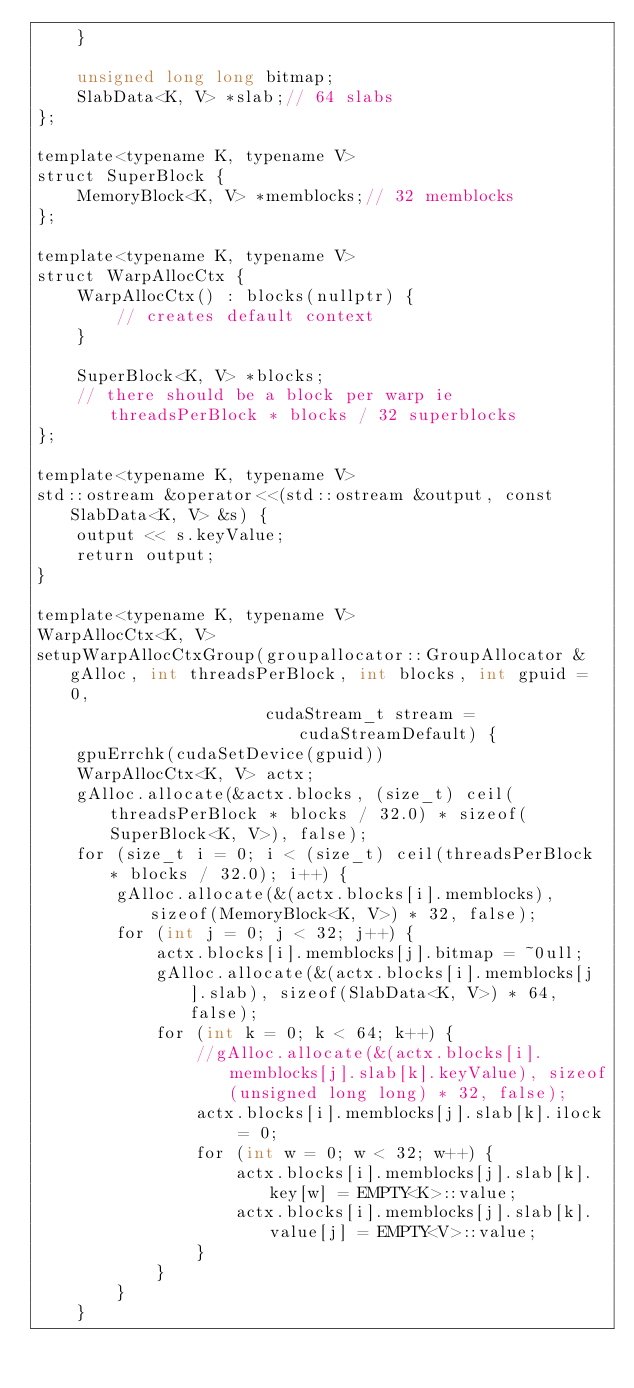Convert code to text. <code><loc_0><loc_0><loc_500><loc_500><_Cuda_>    }

    unsigned long long bitmap;
    SlabData<K, V> *slab;// 64 slabs
};

template<typename K, typename V>
struct SuperBlock {
    MemoryBlock<K, V> *memblocks;// 32 memblocks
};

template<typename K, typename V>
struct WarpAllocCtx {
    WarpAllocCtx() : blocks(nullptr) {
        // creates default context
    }

    SuperBlock<K, V> *blocks;
    // there should be a block per warp ie threadsPerBlock * blocks / 32 superblocks
};

template<typename K, typename V>
std::ostream &operator<<(std::ostream &output, const SlabData<K, V> &s) {
    output << s.keyValue;
    return output;
}

template<typename K, typename V>
WarpAllocCtx<K, V>
setupWarpAllocCtxGroup(groupallocator::GroupAllocator &gAlloc, int threadsPerBlock, int blocks, int gpuid = 0,
                       cudaStream_t stream = cudaStreamDefault) {
    gpuErrchk(cudaSetDevice(gpuid))
    WarpAllocCtx<K, V> actx;
    gAlloc.allocate(&actx.blocks, (size_t) ceil(threadsPerBlock * blocks / 32.0) * sizeof(SuperBlock<K, V>), false);
    for (size_t i = 0; i < (size_t) ceil(threadsPerBlock * blocks / 32.0); i++) {
        gAlloc.allocate(&(actx.blocks[i].memblocks), sizeof(MemoryBlock<K, V>) * 32, false);
        for (int j = 0; j < 32; j++) {
            actx.blocks[i].memblocks[j].bitmap = ~0ull;
            gAlloc.allocate(&(actx.blocks[i].memblocks[j].slab), sizeof(SlabData<K, V>) * 64, false);
            for (int k = 0; k < 64; k++) {
                //gAlloc.allocate(&(actx.blocks[i].memblocks[j].slab[k].keyValue), sizeof(unsigned long long) * 32, false);
                actx.blocks[i].memblocks[j].slab[k].ilock = 0;
                for (int w = 0; w < 32; w++) {
                    actx.blocks[i].memblocks[j].slab[k].key[w] = EMPTY<K>::value;
                    actx.blocks[i].memblocks[j].slab[k].value[j] = EMPTY<V>::value;
                }
            }
        }
    }</code> 